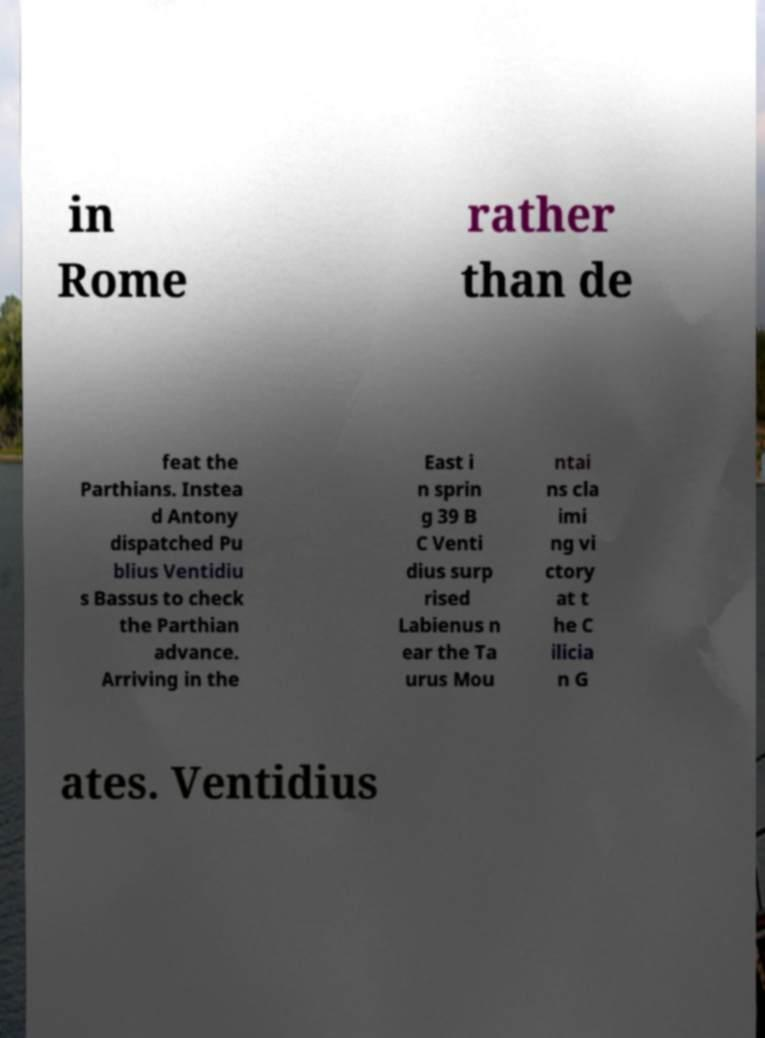What messages or text are displayed in this image? I need them in a readable, typed format. in Rome rather than de feat the Parthians. Instea d Antony dispatched Pu blius Ventidiu s Bassus to check the Parthian advance. Arriving in the East i n sprin g 39 B C Venti dius surp rised Labienus n ear the Ta urus Mou ntai ns cla imi ng vi ctory at t he C ilicia n G ates. Ventidius 